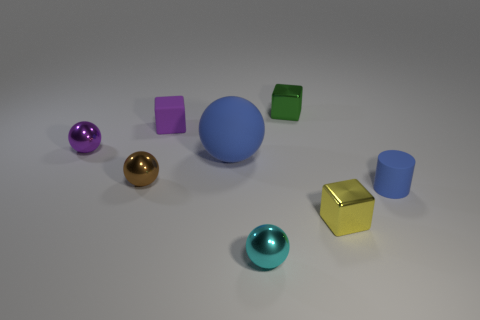What color is the sphere that is to the right of the blue object that is to the left of the small shiny object in front of the tiny yellow metal cube?
Offer a very short reply. Cyan. Is the number of tiny yellow metal objects that are on the left side of the brown sphere the same as the number of large gray metallic things?
Your response must be concise. Yes. There is a cylinder; is it the same color as the large rubber object that is on the left side of the tiny green cube?
Offer a very short reply. Yes. Is there a yellow metallic cube behind the blue rubber thing that is left of the green metal thing that is behind the tiny blue cylinder?
Give a very brief answer. No. Is the number of small yellow blocks that are on the right side of the tiny purple matte object less than the number of red matte cylinders?
Your answer should be compact. No. What number of other things are the same shape as the small green metallic object?
Your response must be concise. 2. How many objects are small matte objects to the right of the yellow shiny thing or metal blocks in front of the tiny purple rubber object?
Provide a short and direct response. 2. How big is the cube that is on the right side of the purple block and behind the small purple metallic ball?
Provide a succinct answer. Small. Is the shape of the big blue thing right of the brown object the same as  the small purple shiny object?
Provide a short and direct response. Yes. What is the size of the metal cube that is in front of the matte thing in front of the blue thing to the left of the small cyan sphere?
Offer a very short reply. Small. 